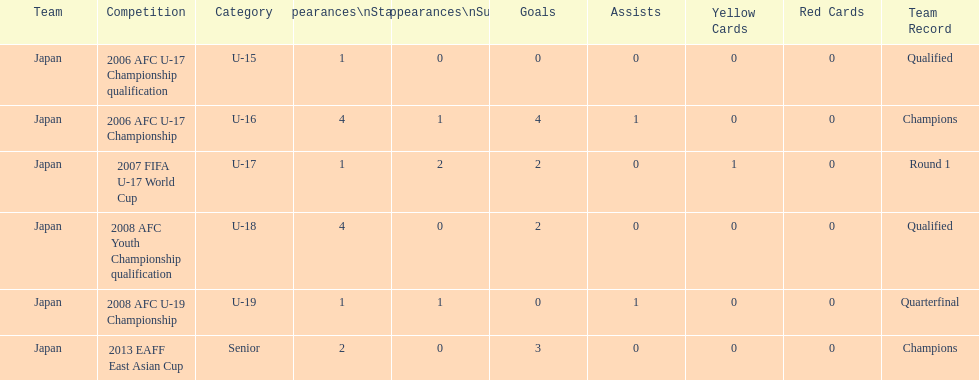Write the full table. {'header': ['Team', 'Competition', 'Category', 'Appearances\\nStart', 'Appearances\\nSub', 'Goals', 'Assists', 'Yellow Cards', 'Red Cards', 'Team Record'], 'rows': [['Japan', '2006 AFC U-17 Championship qualification', 'U-15', '1', '0', '0', '0', '0', '0', 'Qualified'], ['Japan', '2006 AFC U-17 Championship', 'U-16', '4', '1', '4', '1', '0', '0', 'Champions'], ['Japan', '2007 FIFA U-17 World Cup', 'U-17', '1', '2', '2', '0', '1', '0', 'Round 1'], ['Japan', '2008 AFC Youth Championship qualification', 'U-18', '4', '0', '2', '0', '0', '0', 'Qualified'], ['Japan', '2008 AFC U-19 Championship', 'U-19', '1', '1', '0', '1', '0', '0', 'Quarterfinal'], ['Japan', '2013 EAFF East Asian Cup', 'Senior', '2', '0', '3', '0', '0', '0', 'Champions']]} What is the sum of goals scored? 11. 